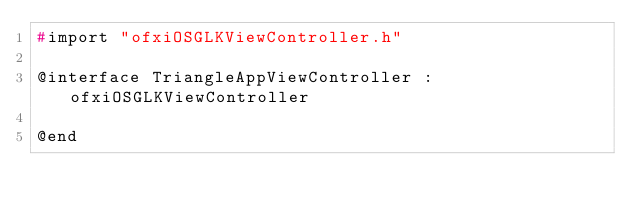<code> <loc_0><loc_0><loc_500><loc_500><_C_>#import "ofxiOSGLKViewController.h"

@interface TriangleAppViewController : ofxiOSGLKViewController

@end
</code> 